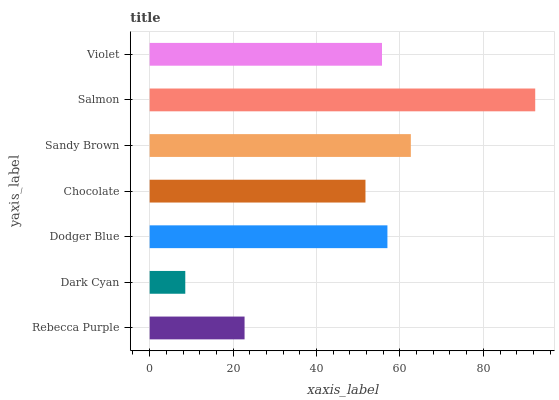Is Dark Cyan the minimum?
Answer yes or no. Yes. Is Salmon the maximum?
Answer yes or no. Yes. Is Dodger Blue the minimum?
Answer yes or no. No. Is Dodger Blue the maximum?
Answer yes or no. No. Is Dodger Blue greater than Dark Cyan?
Answer yes or no. Yes. Is Dark Cyan less than Dodger Blue?
Answer yes or no. Yes. Is Dark Cyan greater than Dodger Blue?
Answer yes or no. No. Is Dodger Blue less than Dark Cyan?
Answer yes or no. No. Is Violet the high median?
Answer yes or no. Yes. Is Violet the low median?
Answer yes or no. Yes. Is Rebecca Purple the high median?
Answer yes or no. No. Is Dodger Blue the low median?
Answer yes or no. No. 